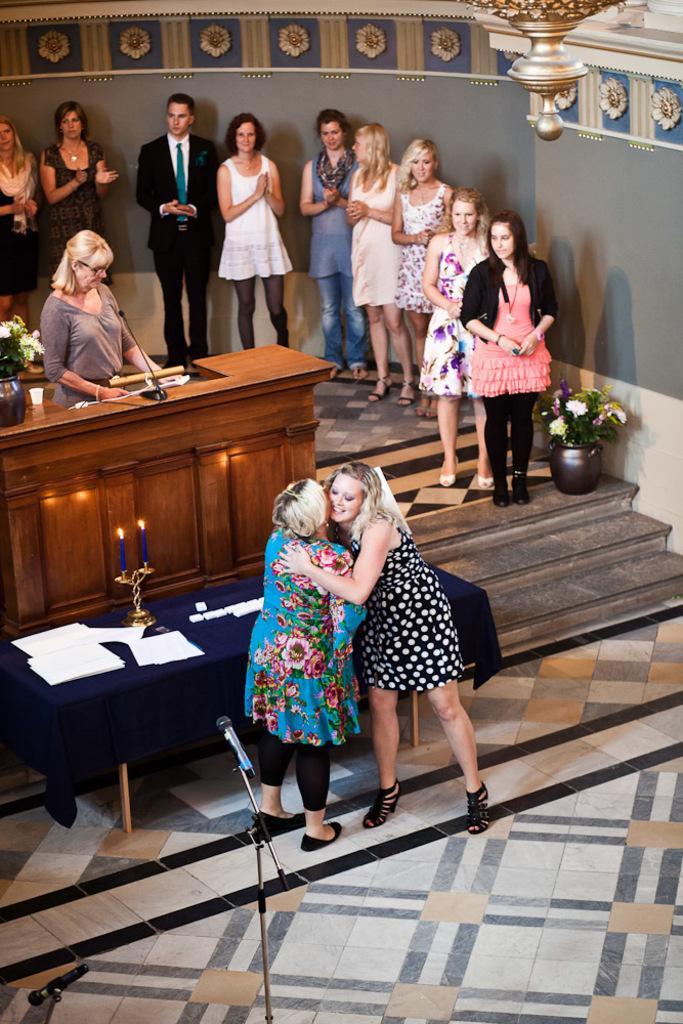Can you describe this image briefly? In this image there are group of people who are standing and in the middle there are two woman who are standing and hugging each other in front of them there is one mike beside them there is one table on that table there are some papers and that table is covered with blue a cloth and some candles are there on the table. Beside that table there is another table and mike is there. On the left side there is one woman who is standing it seems that she is talking. Beside her one flower pot one plant on the right side there is wall and in the right side of the middle there are some stairs and one flower pot and one plant is there. 